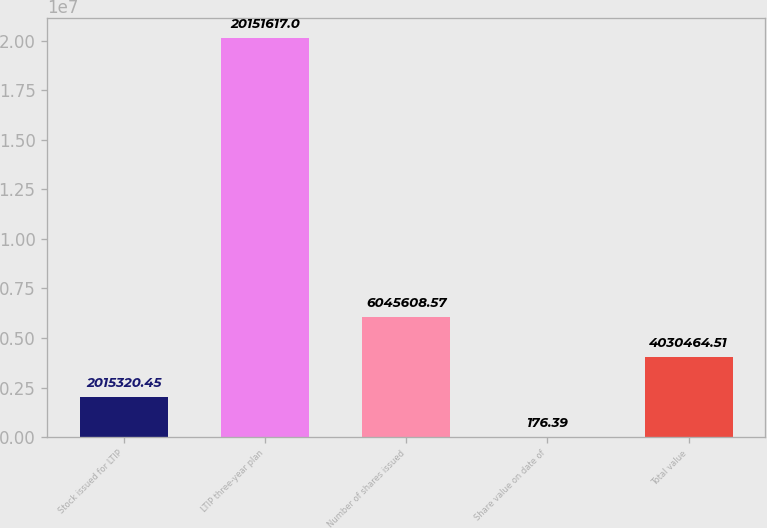Convert chart. <chart><loc_0><loc_0><loc_500><loc_500><bar_chart><fcel>Stock issued for LTIP<fcel>LTIP three-year plan<fcel>Number of shares issued<fcel>Share value on date of<fcel>Total value<nl><fcel>2.01532e+06<fcel>2.01516e+07<fcel>6.04561e+06<fcel>176.39<fcel>4.03046e+06<nl></chart> 